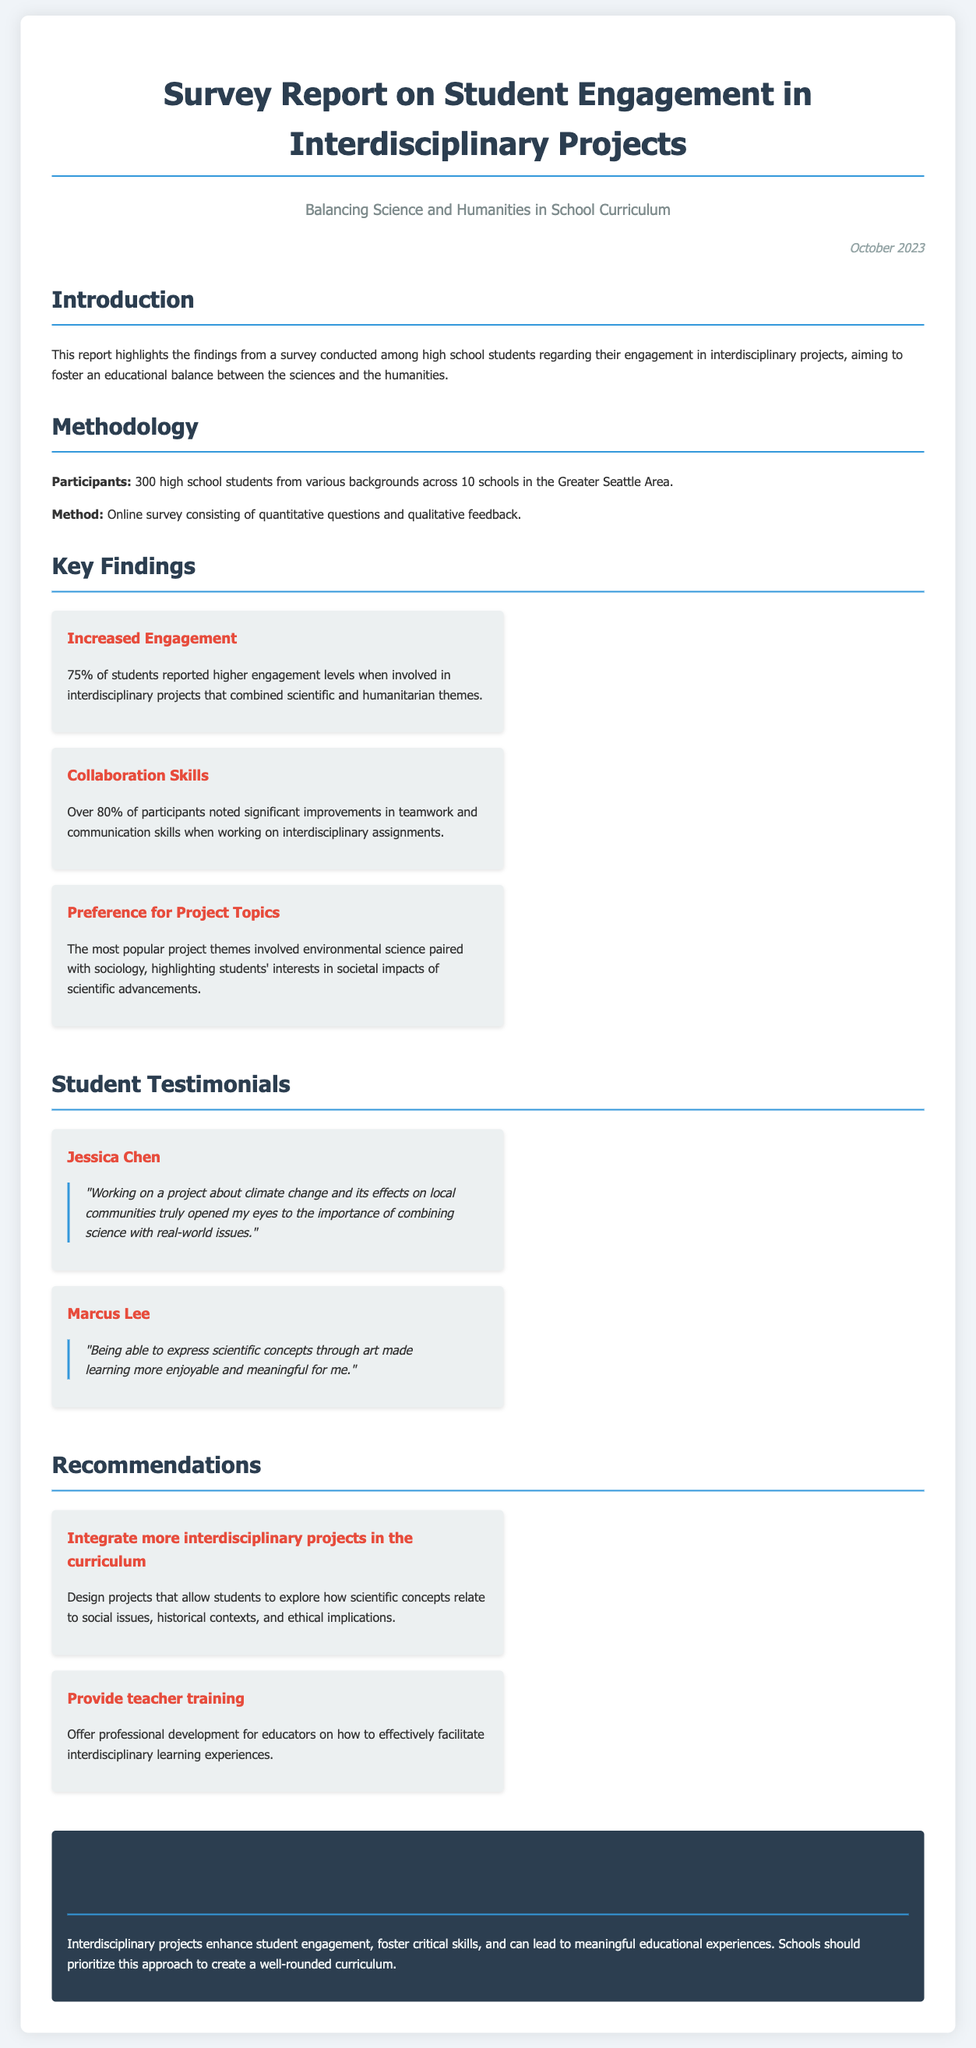What percentage of students reported higher engagement levels? The document states that 75% of students reported higher engagement levels when involved in interdisciplinary projects.
Answer: 75% How many high school students participated in the survey? The methodology section mentions that 300 high school students from various backgrounds participated in the survey.
Answer: 300 What was a popular project theme among students? The key findings highlight that the most popular project themes involved environmental science paired with sociology.
Answer: Environmental science paired with sociology Who said, "Being able to express scientific concepts through art made learning more enjoyable and meaningful for me"? The testimonials section includes a quote from Marcus Lee, who expressed this sentiment about interdisciplinary projects.
Answer: Marcus Lee What is one recommendation for educators in the report? One recommendation provided in the report is to offer professional development for educators on facilitating interdisciplinary learning experiences.
Answer: Provide teacher training How does the report suggest interdisciplinary projects affect teamwork? According to the key findings, over 80% of participants noted significant improvements in teamwork when working on interdisciplinary assignments.
Answer: Significant improvements What are the two areas mentioned to balance in the school curriculum? The report focuses on finding a balance between science and humanities in the school curriculum.
Answer: Science and humanities What is the title of the report? The report is titled "Survey Report on Student Engagement in Interdisciplinary Projects".
Answer: Survey Report on Student Engagement in Interdisciplinary Projects 